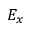<formula> <loc_0><loc_0><loc_500><loc_500>E _ { x }</formula> 